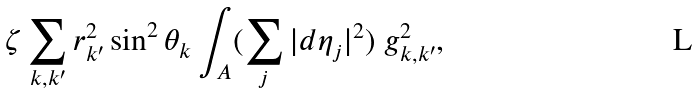Convert formula to latex. <formula><loc_0><loc_0><loc_500><loc_500>\zeta \sum _ { k , k ^ { \prime } } r _ { k ^ { \prime } } ^ { 2 } \sin ^ { 2 } \theta _ { k } \int _ { A } ( \sum _ { j } | d \eta _ { j } | ^ { 2 } ) \ g _ { k , k ^ { \prime } } ^ { 2 } ,</formula> 